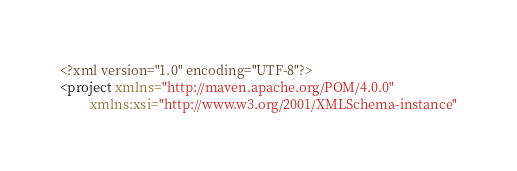<code> <loc_0><loc_0><loc_500><loc_500><_XML_><?xml version="1.0" encoding="UTF-8"?>
<project xmlns="http://maven.apache.org/POM/4.0.0"
         xmlns:xsi="http://www.w3.org/2001/XMLSchema-instance"</code> 